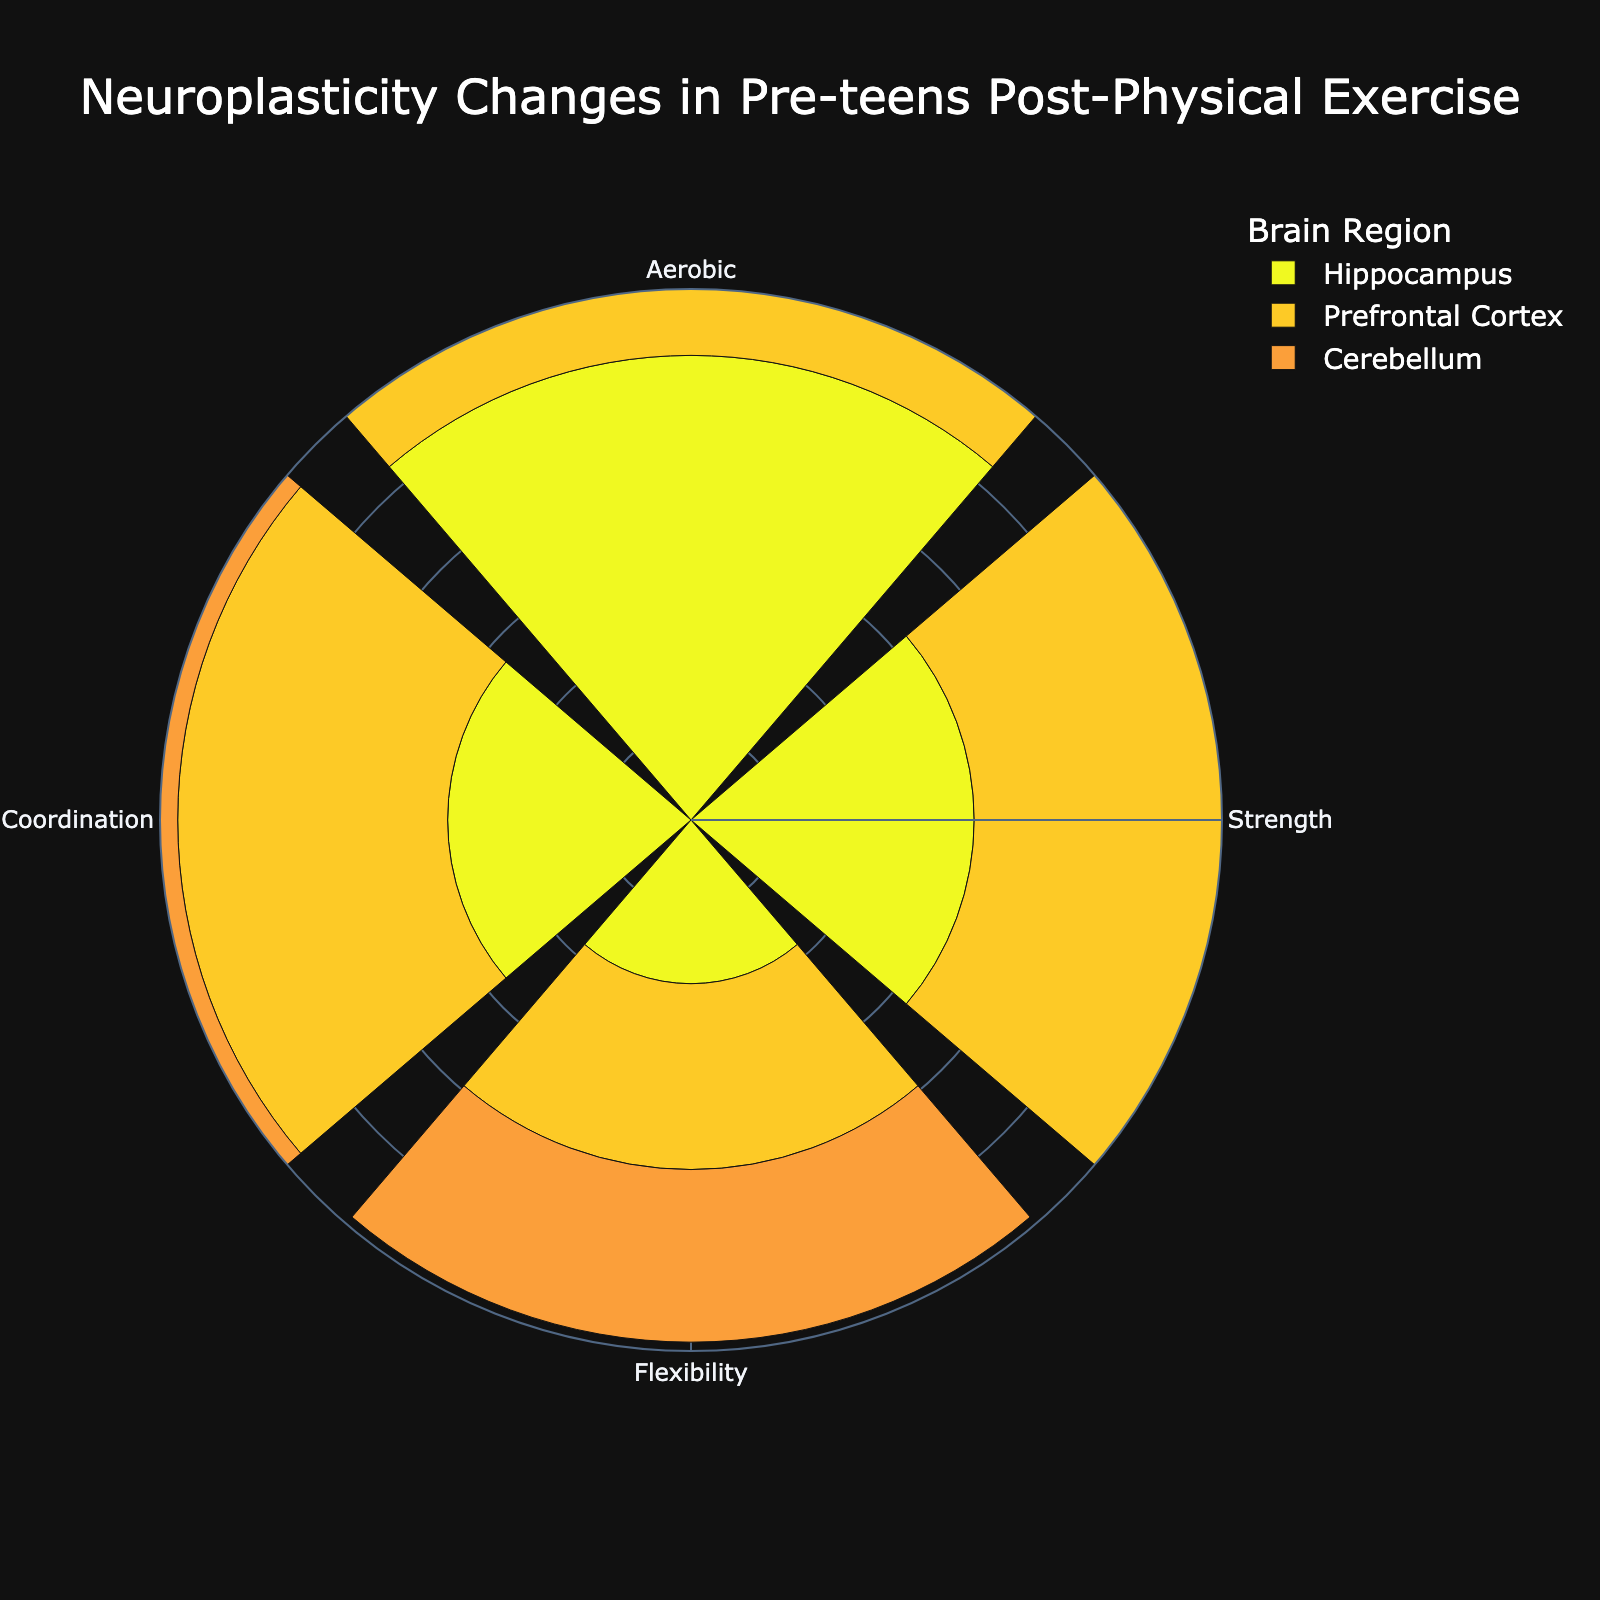Which brain region has the highest neuroplasticity change from aerobic exercise? From the rose chart, you can observe that the hippocampus section of the aerobic exercise sector reaches the highest radial length, indicating the largest neuroplasticity change.
Answer: Hippocampus Which activity type shows the least change in the hippocampus? Check for the activity type linked to the smallest radial length within the hippocampus brain region across all sectors. Flexibility exercises show the least change.
Answer: Flexibility Exercise What is the total neuroplasticity change percentage for the cerebellum across all activity types? Sum up the radial lengths representing the neuroplasticity changes for the cerebellum across all four activity types: Aerobic (7.9), Strength (6.1), Flexibility (3.9), and Coordination (7.0). The total is 7.9 + 6.1 + 3.9 + 7.0.
Answer: 24.9% Which brain region shows the most uniform changes across all the activity types? Identify the brain region where the radial lengths (neuroplasticity changes) are most similar in size across all activity types: Hippocampus, Prefrontal Cortex, and Cerebellum. The prefrontal cortex has values 8.2, 5.8, 4.2, and 6.1, which suggest relatively minimal variation.
Answer: Prefrontal Cortex Does the prefrontal cortex demonstrate higher neuroplasticity changes from coordination or strength training? Compare the radial lengths for the prefrontal cortex under coordination (6.1) and strength training (5.8) activities. Coordination exercise shows a higher value.
Answer: Coordination Exercise What is the average neuroplasticity change percentage for strength training across all brain regions? Sum the radial lengths representing the neuroplasticity changes for strength training across all three brain regions and divide by 3: (6.4 + 5.8 + 6.1) / 3.
Answer: 6.1% Which activity type results in the most substantial average neuroplasticity change across all brain regions? Calculate the average neuroplasticity change for each activity type (sum of radial lengths for all brain regions divided by 3). Aerobic Exercise: (10.5 + 8.2 + 7.9) / 3 = 8.87; Strength Training: (6.4 + 5.8 + 6.1) / 3 = 6.1; Flexibility Exercise: (3.7 + 4.2 + 3.9) / 3 = 3.93; Coordination Exercise: (5.5 + 6.1 + 7.0) / 3 = 6.2. Aerobic Exercise has the highest average.
Answer: Aerobic Exercise Which combination of brain region and activity type shows the highest neuroplasticity change percentage? Check all brain regions and their corresponding highest radial length across all activity types. The highest is the hippocampus region under aerobic exercise at 10.5%.
Answer: Hippocampus and Aerobic Exercise How does the neuroplasticity change percentage for the prefrontal cortex from flexibility exercises compare to that from aerobic exercises? Compare the radial lengths for the prefrontal cortex under flexibility (4.2) and aerobic (8.2), revealing a lower value for flexibility exercises.
Answer: Lower Which exercise type leads to the highest neuroplasticity change in the cerebellum? Identify the activity type associated with the longest radial length in the cerebellum segment. Coordination exercise shows the highest change with 7.0%.
Answer: Coordination Exercise 